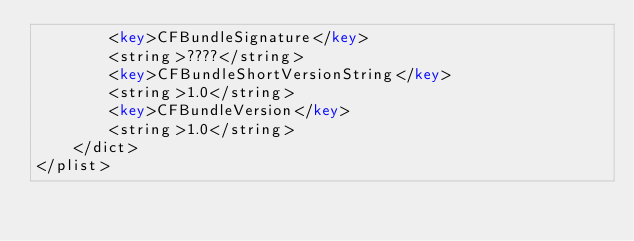<code> <loc_0><loc_0><loc_500><loc_500><_XML_>		<key>CFBundleSignature</key>
		<string>????</string>
		<key>CFBundleShortVersionString</key>
		<string>1.0</string>
		<key>CFBundleVersion</key>
		<string>1.0</string>
	</dict>
</plist>
</code> 